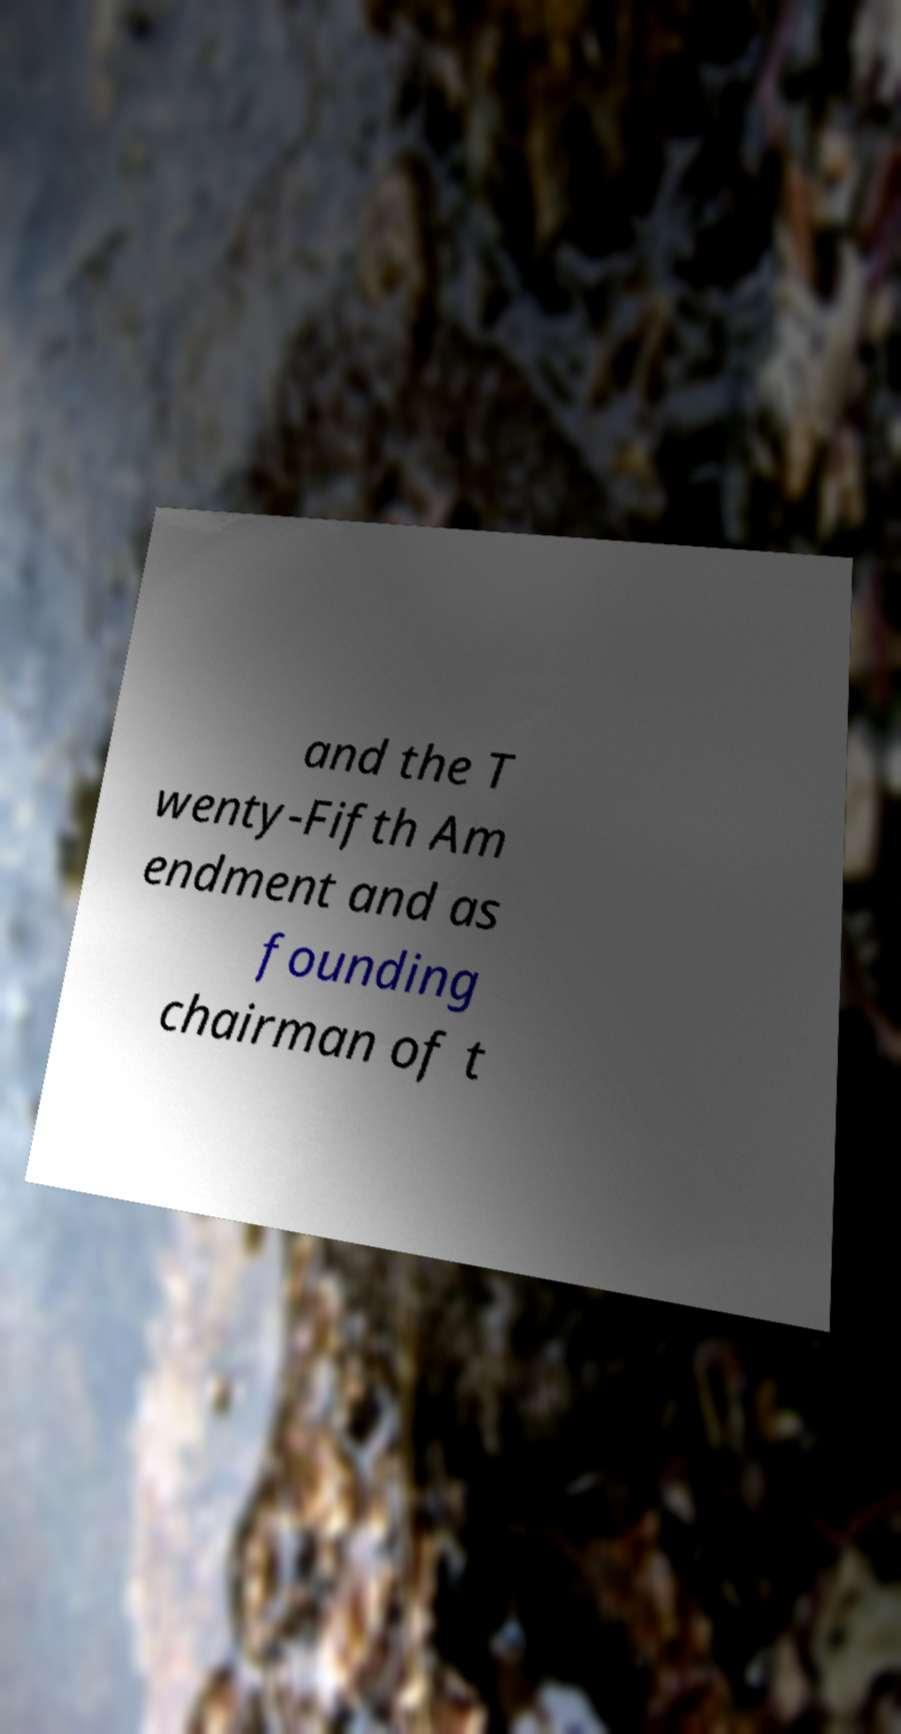Can you accurately transcribe the text from the provided image for me? and the T wenty-Fifth Am endment and as founding chairman of t 